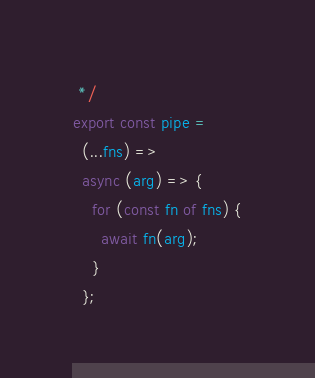Convert code to text. <code><loc_0><loc_0><loc_500><loc_500><_TypeScript_> */
export const pipe =
  (...fns) =>
  async (arg) => {
    for (const fn of fns) {
      await fn(arg);
    }
  };
</code> 